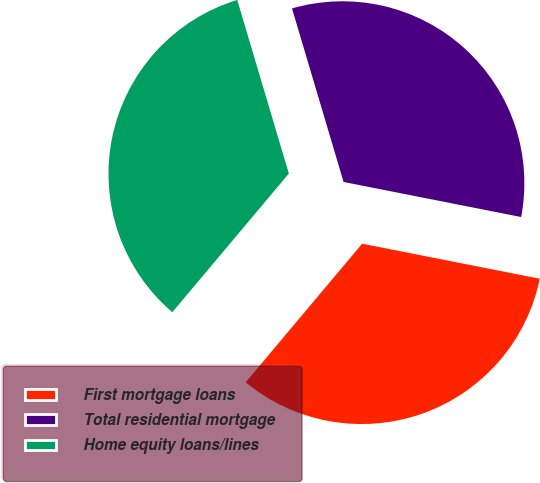Convert chart to OTSL. <chart><loc_0><loc_0><loc_500><loc_500><pie_chart><fcel>First mortgage loans<fcel>Total residential mortgage<fcel>Home equity loans/lines<nl><fcel>33.02%<fcel>32.7%<fcel>34.28%<nl></chart> 